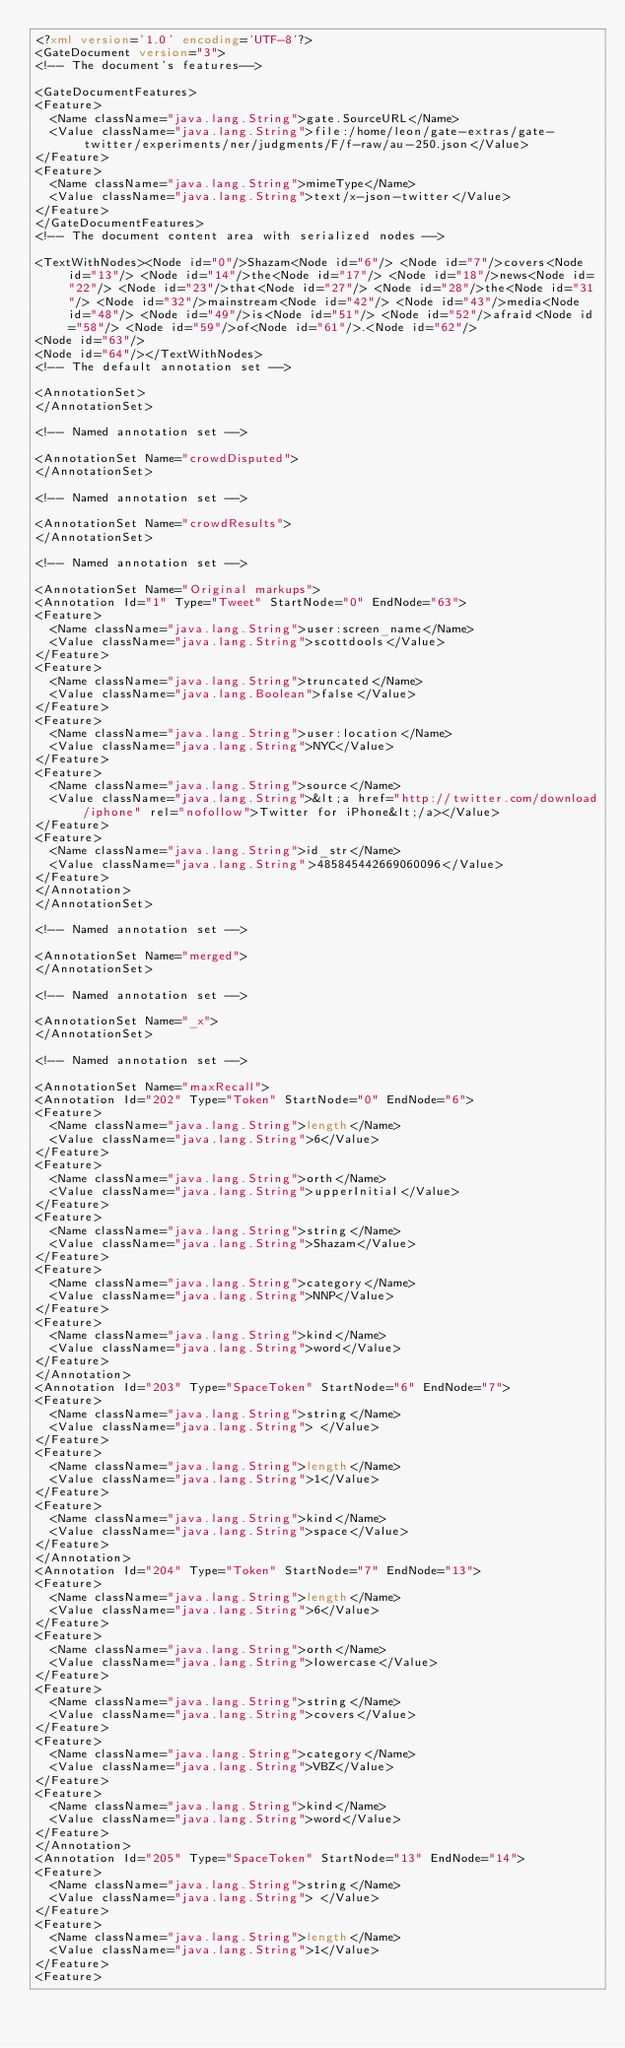<code> <loc_0><loc_0><loc_500><loc_500><_XML_><?xml version='1.0' encoding='UTF-8'?>
<GateDocument version="3">
<!-- The document's features-->

<GateDocumentFeatures>
<Feature>
  <Name className="java.lang.String">gate.SourceURL</Name>
  <Value className="java.lang.String">file:/home/leon/gate-extras/gate-twitter/experiments/ner/judgments/F/f-raw/au-250.json</Value>
</Feature>
<Feature>
  <Name className="java.lang.String">mimeType</Name>
  <Value className="java.lang.String">text/x-json-twitter</Value>
</Feature>
</GateDocumentFeatures>
<!-- The document content area with serialized nodes -->

<TextWithNodes><Node id="0"/>Shazam<Node id="6"/> <Node id="7"/>covers<Node id="13"/> <Node id="14"/>the<Node id="17"/> <Node id="18"/>news<Node id="22"/> <Node id="23"/>that<Node id="27"/> <Node id="28"/>the<Node id="31"/> <Node id="32"/>mainstream<Node id="42"/> <Node id="43"/>media<Node id="48"/> <Node id="49"/>is<Node id="51"/> <Node id="52"/>afraid<Node id="58"/> <Node id="59"/>of<Node id="61"/>.<Node id="62"/>
<Node id="63"/>
<Node id="64"/></TextWithNodes>
<!-- The default annotation set -->

<AnnotationSet>
</AnnotationSet>

<!-- Named annotation set -->

<AnnotationSet Name="crowdDisputed">
</AnnotationSet>

<!-- Named annotation set -->

<AnnotationSet Name="crowdResults">
</AnnotationSet>

<!-- Named annotation set -->

<AnnotationSet Name="Original markups">
<Annotation Id="1" Type="Tweet" StartNode="0" EndNode="63">
<Feature>
  <Name className="java.lang.String">user:screen_name</Name>
  <Value className="java.lang.String">scottdools</Value>
</Feature>
<Feature>
  <Name className="java.lang.String">truncated</Name>
  <Value className="java.lang.Boolean">false</Value>
</Feature>
<Feature>
  <Name className="java.lang.String">user:location</Name>
  <Value className="java.lang.String">NYC</Value>
</Feature>
<Feature>
  <Name className="java.lang.String">source</Name>
  <Value className="java.lang.String">&lt;a href="http://twitter.com/download/iphone" rel="nofollow">Twitter for iPhone&lt;/a></Value>
</Feature>
<Feature>
  <Name className="java.lang.String">id_str</Name>
  <Value className="java.lang.String">485845442669060096</Value>
</Feature>
</Annotation>
</AnnotationSet>

<!-- Named annotation set -->

<AnnotationSet Name="merged">
</AnnotationSet>

<!-- Named annotation set -->

<AnnotationSet Name="_x">
</AnnotationSet>

<!-- Named annotation set -->

<AnnotationSet Name="maxRecall">
<Annotation Id="202" Type="Token" StartNode="0" EndNode="6">
<Feature>
  <Name className="java.lang.String">length</Name>
  <Value className="java.lang.String">6</Value>
</Feature>
<Feature>
  <Name className="java.lang.String">orth</Name>
  <Value className="java.lang.String">upperInitial</Value>
</Feature>
<Feature>
  <Name className="java.lang.String">string</Name>
  <Value className="java.lang.String">Shazam</Value>
</Feature>
<Feature>
  <Name className="java.lang.String">category</Name>
  <Value className="java.lang.String">NNP</Value>
</Feature>
<Feature>
  <Name className="java.lang.String">kind</Name>
  <Value className="java.lang.String">word</Value>
</Feature>
</Annotation>
<Annotation Id="203" Type="SpaceToken" StartNode="6" EndNode="7">
<Feature>
  <Name className="java.lang.String">string</Name>
  <Value className="java.lang.String"> </Value>
</Feature>
<Feature>
  <Name className="java.lang.String">length</Name>
  <Value className="java.lang.String">1</Value>
</Feature>
<Feature>
  <Name className="java.lang.String">kind</Name>
  <Value className="java.lang.String">space</Value>
</Feature>
</Annotation>
<Annotation Id="204" Type="Token" StartNode="7" EndNode="13">
<Feature>
  <Name className="java.lang.String">length</Name>
  <Value className="java.lang.String">6</Value>
</Feature>
<Feature>
  <Name className="java.lang.String">orth</Name>
  <Value className="java.lang.String">lowercase</Value>
</Feature>
<Feature>
  <Name className="java.lang.String">string</Name>
  <Value className="java.lang.String">covers</Value>
</Feature>
<Feature>
  <Name className="java.lang.String">category</Name>
  <Value className="java.lang.String">VBZ</Value>
</Feature>
<Feature>
  <Name className="java.lang.String">kind</Name>
  <Value className="java.lang.String">word</Value>
</Feature>
</Annotation>
<Annotation Id="205" Type="SpaceToken" StartNode="13" EndNode="14">
<Feature>
  <Name className="java.lang.String">string</Name>
  <Value className="java.lang.String"> </Value>
</Feature>
<Feature>
  <Name className="java.lang.String">length</Name>
  <Value className="java.lang.String">1</Value>
</Feature>
<Feature></code> 